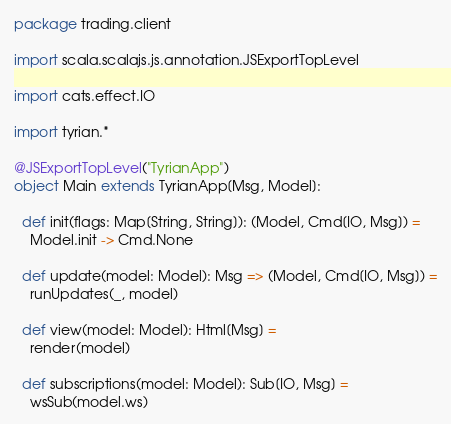Convert code to text. <code><loc_0><loc_0><loc_500><loc_500><_Scala_>package trading.client

import scala.scalajs.js.annotation.JSExportTopLevel

import cats.effect.IO

import tyrian.*

@JSExportTopLevel("TyrianApp")
object Main extends TyrianApp[Msg, Model]:

  def init(flags: Map[String, String]): (Model, Cmd[IO, Msg]) =
    Model.init -> Cmd.None

  def update(model: Model): Msg => (Model, Cmd[IO, Msg]) =
    runUpdates(_, model)

  def view(model: Model): Html[Msg] =
    render(model)

  def subscriptions(model: Model): Sub[IO, Msg] =
    wsSub(model.ws)
</code> 